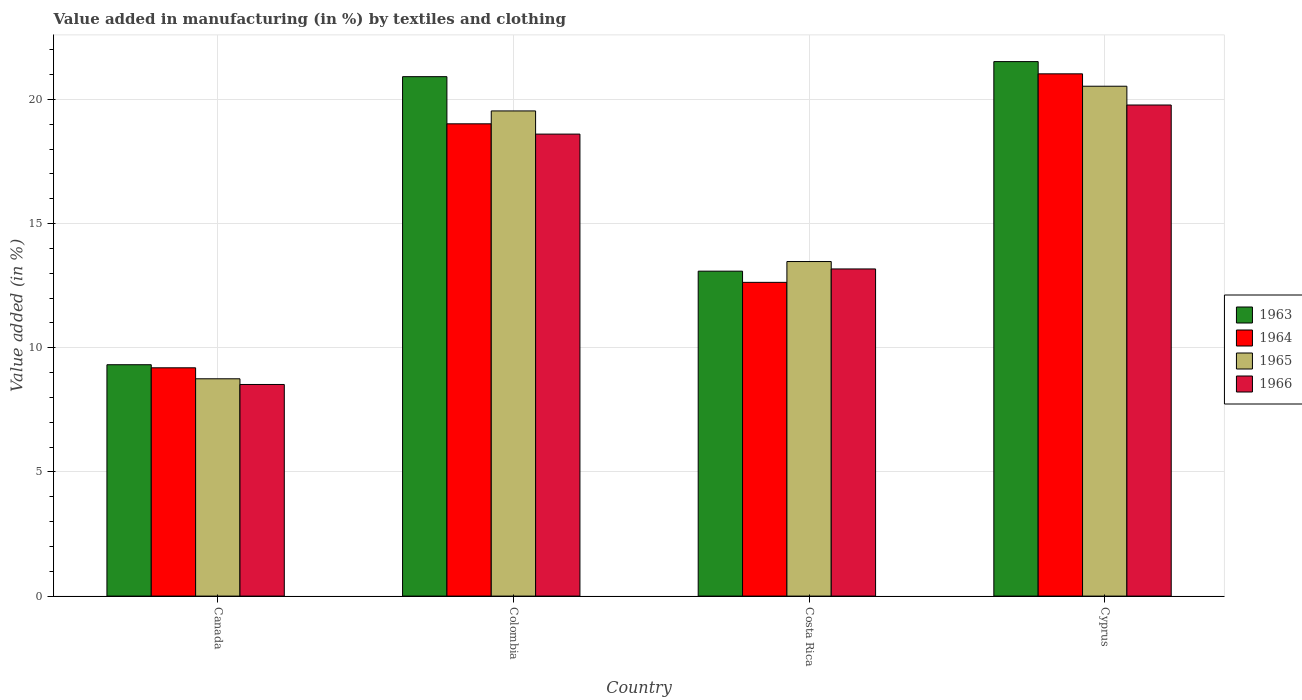How many different coloured bars are there?
Provide a short and direct response. 4. What is the label of the 3rd group of bars from the left?
Provide a short and direct response. Costa Rica. What is the percentage of value added in manufacturing by textiles and clothing in 1966 in Canada?
Your response must be concise. 8.52. Across all countries, what is the maximum percentage of value added in manufacturing by textiles and clothing in 1964?
Offer a terse response. 21.03. Across all countries, what is the minimum percentage of value added in manufacturing by textiles and clothing in 1966?
Provide a succinct answer. 8.52. In which country was the percentage of value added in manufacturing by textiles and clothing in 1965 maximum?
Ensure brevity in your answer.  Cyprus. In which country was the percentage of value added in manufacturing by textiles and clothing in 1965 minimum?
Make the answer very short. Canada. What is the total percentage of value added in manufacturing by textiles and clothing in 1965 in the graph?
Keep it short and to the point. 62.29. What is the difference between the percentage of value added in manufacturing by textiles and clothing in 1965 in Colombia and that in Costa Rica?
Keep it short and to the point. 6.06. What is the difference between the percentage of value added in manufacturing by textiles and clothing in 1965 in Canada and the percentage of value added in manufacturing by textiles and clothing in 1966 in Costa Rica?
Keep it short and to the point. -4.42. What is the average percentage of value added in manufacturing by textiles and clothing in 1963 per country?
Offer a very short reply. 16.21. What is the difference between the percentage of value added in manufacturing by textiles and clothing of/in 1966 and percentage of value added in manufacturing by textiles and clothing of/in 1964 in Colombia?
Offer a terse response. -0.41. What is the ratio of the percentage of value added in manufacturing by textiles and clothing in 1966 in Colombia to that in Cyprus?
Give a very brief answer. 0.94. Is the percentage of value added in manufacturing by textiles and clothing in 1965 in Colombia less than that in Costa Rica?
Your answer should be compact. No. Is the difference between the percentage of value added in manufacturing by textiles and clothing in 1966 in Canada and Colombia greater than the difference between the percentage of value added in manufacturing by textiles and clothing in 1964 in Canada and Colombia?
Provide a short and direct response. No. What is the difference between the highest and the second highest percentage of value added in manufacturing by textiles and clothing in 1963?
Your answer should be very brief. -7.83. What is the difference between the highest and the lowest percentage of value added in manufacturing by textiles and clothing in 1963?
Your answer should be compact. 12.21. In how many countries, is the percentage of value added in manufacturing by textiles and clothing in 1963 greater than the average percentage of value added in manufacturing by textiles and clothing in 1963 taken over all countries?
Provide a short and direct response. 2. Is the sum of the percentage of value added in manufacturing by textiles and clothing in 1965 in Canada and Costa Rica greater than the maximum percentage of value added in manufacturing by textiles and clothing in 1964 across all countries?
Give a very brief answer. Yes. What does the 2nd bar from the left in Colombia represents?
Provide a succinct answer. 1964. What does the 1st bar from the right in Canada represents?
Ensure brevity in your answer.  1966. Is it the case that in every country, the sum of the percentage of value added in manufacturing by textiles and clothing in 1966 and percentage of value added in manufacturing by textiles and clothing in 1965 is greater than the percentage of value added in manufacturing by textiles and clothing in 1964?
Ensure brevity in your answer.  Yes. How many countries are there in the graph?
Offer a terse response. 4. Does the graph contain grids?
Give a very brief answer. Yes. Where does the legend appear in the graph?
Keep it short and to the point. Center right. How are the legend labels stacked?
Ensure brevity in your answer.  Vertical. What is the title of the graph?
Offer a terse response. Value added in manufacturing (in %) by textiles and clothing. What is the label or title of the Y-axis?
Offer a terse response. Value added (in %). What is the Value added (in %) in 1963 in Canada?
Your answer should be very brief. 9.32. What is the Value added (in %) of 1964 in Canada?
Keep it short and to the point. 9.19. What is the Value added (in %) in 1965 in Canada?
Your response must be concise. 8.75. What is the Value added (in %) of 1966 in Canada?
Your answer should be compact. 8.52. What is the Value added (in %) of 1963 in Colombia?
Your answer should be very brief. 20.92. What is the Value added (in %) of 1964 in Colombia?
Your answer should be compact. 19.02. What is the Value added (in %) of 1965 in Colombia?
Make the answer very short. 19.54. What is the Value added (in %) of 1966 in Colombia?
Offer a very short reply. 18.6. What is the Value added (in %) of 1963 in Costa Rica?
Your response must be concise. 13.08. What is the Value added (in %) in 1964 in Costa Rica?
Your response must be concise. 12.63. What is the Value added (in %) in 1965 in Costa Rica?
Offer a very short reply. 13.47. What is the Value added (in %) in 1966 in Costa Rica?
Provide a succinct answer. 13.17. What is the Value added (in %) of 1963 in Cyprus?
Your answer should be very brief. 21.52. What is the Value added (in %) in 1964 in Cyprus?
Offer a very short reply. 21.03. What is the Value added (in %) in 1965 in Cyprus?
Provide a succinct answer. 20.53. What is the Value added (in %) in 1966 in Cyprus?
Give a very brief answer. 19.78. Across all countries, what is the maximum Value added (in %) of 1963?
Give a very brief answer. 21.52. Across all countries, what is the maximum Value added (in %) of 1964?
Your response must be concise. 21.03. Across all countries, what is the maximum Value added (in %) of 1965?
Make the answer very short. 20.53. Across all countries, what is the maximum Value added (in %) in 1966?
Make the answer very short. 19.78. Across all countries, what is the minimum Value added (in %) in 1963?
Keep it short and to the point. 9.32. Across all countries, what is the minimum Value added (in %) in 1964?
Provide a short and direct response. 9.19. Across all countries, what is the minimum Value added (in %) of 1965?
Make the answer very short. 8.75. Across all countries, what is the minimum Value added (in %) of 1966?
Keep it short and to the point. 8.52. What is the total Value added (in %) of 1963 in the graph?
Provide a succinct answer. 64.84. What is the total Value added (in %) of 1964 in the graph?
Your answer should be compact. 61.88. What is the total Value added (in %) of 1965 in the graph?
Your answer should be compact. 62.29. What is the total Value added (in %) in 1966 in the graph?
Offer a terse response. 60.08. What is the difference between the Value added (in %) of 1963 in Canada and that in Colombia?
Make the answer very short. -11.6. What is the difference between the Value added (in %) in 1964 in Canada and that in Colombia?
Your answer should be very brief. -9.82. What is the difference between the Value added (in %) in 1965 in Canada and that in Colombia?
Offer a very short reply. -10.79. What is the difference between the Value added (in %) of 1966 in Canada and that in Colombia?
Offer a very short reply. -10.08. What is the difference between the Value added (in %) of 1963 in Canada and that in Costa Rica?
Give a very brief answer. -3.77. What is the difference between the Value added (in %) of 1964 in Canada and that in Costa Rica?
Provide a succinct answer. -3.44. What is the difference between the Value added (in %) of 1965 in Canada and that in Costa Rica?
Offer a very short reply. -4.72. What is the difference between the Value added (in %) of 1966 in Canada and that in Costa Rica?
Keep it short and to the point. -4.65. What is the difference between the Value added (in %) in 1963 in Canada and that in Cyprus?
Ensure brevity in your answer.  -12.21. What is the difference between the Value added (in %) of 1964 in Canada and that in Cyprus?
Offer a very short reply. -11.84. What is the difference between the Value added (in %) in 1965 in Canada and that in Cyprus?
Provide a succinct answer. -11.78. What is the difference between the Value added (in %) of 1966 in Canada and that in Cyprus?
Offer a terse response. -11.25. What is the difference between the Value added (in %) of 1963 in Colombia and that in Costa Rica?
Offer a terse response. 7.83. What is the difference between the Value added (in %) in 1964 in Colombia and that in Costa Rica?
Offer a very short reply. 6.38. What is the difference between the Value added (in %) in 1965 in Colombia and that in Costa Rica?
Offer a terse response. 6.06. What is the difference between the Value added (in %) of 1966 in Colombia and that in Costa Rica?
Your answer should be very brief. 5.43. What is the difference between the Value added (in %) in 1963 in Colombia and that in Cyprus?
Your answer should be compact. -0.61. What is the difference between the Value added (in %) of 1964 in Colombia and that in Cyprus?
Offer a terse response. -2.01. What is the difference between the Value added (in %) of 1965 in Colombia and that in Cyprus?
Offer a terse response. -0.99. What is the difference between the Value added (in %) of 1966 in Colombia and that in Cyprus?
Make the answer very short. -1.17. What is the difference between the Value added (in %) of 1963 in Costa Rica and that in Cyprus?
Offer a terse response. -8.44. What is the difference between the Value added (in %) of 1964 in Costa Rica and that in Cyprus?
Your answer should be very brief. -8.4. What is the difference between the Value added (in %) of 1965 in Costa Rica and that in Cyprus?
Ensure brevity in your answer.  -7.06. What is the difference between the Value added (in %) of 1966 in Costa Rica and that in Cyprus?
Offer a very short reply. -6.6. What is the difference between the Value added (in %) of 1963 in Canada and the Value added (in %) of 1964 in Colombia?
Your answer should be very brief. -9.7. What is the difference between the Value added (in %) of 1963 in Canada and the Value added (in %) of 1965 in Colombia?
Your answer should be very brief. -10.22. What is the difference between the Value added (in %) in 1963 in Canada and the Value added (in %) in 1966 in Colombia?
Offer a terse response. -9.29. What is the difference between the Value added (in %) in 1964 in Canada and the Value added (in %) in 1965 in Colombia?
Ensure brevity in your answer.  -10.34. What is the difference between the Value added (in %) of 1964 in Canada and the Value added (in %) of 1966 in Colombia?
Keep it short and to the point. -9.41. What is the difference between the Value added (in %) of 1965 in Canada and the Value added (in %) of 1966 in Colombia?
Provide a succinct answer. -9.85. What is the difference between the Value added (in %) of 1963 in Canada and the Value added (in %) of 1964 in Costa Rica?
Offer a very short reply. -3.32. What is the difference between the Value added (in %) of 1963 in Canada and the Value added (in %) of 1965 in Costa Rica?
Give a very brief answer. -4.16. What is the difference between the Value added (in %) in 1963 in Canada and the Value added (in %) in 1966 in Costa Rica?
Provide a short and direct response. -3.86. What is the difference between the Value added (in %) in 1964 in Canada and the Value added (in %) in 1965 in Costa Rica?
Your answer should be very brief. -4.28. What is the difference between the Value added (in %) of 1964 in Canada and the Value added (in %) of 1966 in Costa Rica?
Your response must be concise. -3.98. What is the difference between the Value added (in %) in 1965 in Canada and the Value added (in %) in 1966 in Costa Rica?
Give a very brief answer. -4.42. What is the difference between the Value added (in %) in 1963 in Canada and the Value added (in %) in 1964 in Cyprus?
Your response must be concise. -11.71. What is the difference between the Value added (in %) in 1963 in Canada and the Value added (in %) in 1965 in Cyprus?
Offer a terse response. -11.21. What is the difference between the Value added (in %) of 1963 in Canada and the Value added (in %) of 1966 in Cyprus?
Offer a very short reply. -10.46. What is the difference between the Value added (in %) of 1964 in Canada and the Value added (in %) of 1965 in Cyprus?
Ensure brevity in your answer.  -11.34. What is the difference between the Value added (in %) of 1964 in Canada and the Value added (in %) of 1966 in Cyprus?
Give a very brief answer. -10.58. What is the difference between the Value added (in %) in 1965 in Canada and the Value added (in %) in 1966 in Cyprus?
Provide a succinct answer. -11.02. What is the difference between the Value added (in %) in 1963 in Colombia and the Value added (in %) in 1964 in Costa Rica?
Provide a succinct answer. 8.28. What is the difference between the Value added (in %) of 1963 in Colombia and the Value added (in %) of 1965 in Costa Rica?
Ensure brevity in your answer.  7.44. What is the difference between the Value added (in %) in 1963 in Colombia and the Value added (in %) in 1966 in Costa Rica?
Your answer should be compact. 7.74. What is the difference between the Value added (in %) of 1964 in Colombia and the Value added (in %) of 1965 in Costa Rica?
Keep it short and to the point. 5.55. What is the difference between the Value added (in %) of 1964 in Colombia and the Value added (in %) of 1966 in Costa Rica?
Keep it short and to the point. 5.84. What is the difference between the Value added (in %) in 1965 in Colombia and the Value added (in %) in 1966 in Costa Rica?
Ensure brevity in your answer.  6.36. What is the difference between the Value added (in %) of 1963 in Colombia and the Value added (in %) of 1964 in Cyprus?
Keep it short and to the point. -0.11. What is the difference between the Value added (in %) in 1963 in Colombia and the Value added (in %) in 1965 in Cyprus?
Offer a terse response. 0.39. What is the difference between the Value added (in %) in 1963 in Colombia and the Value added (in %) in 1966 in Cyprus?
Your answer should be very brief. 1.14. What is the difference between the Value added (in %) of 1964 in Colombia and the Value added (in %) of 1965 in Cyprus?
Your answer should be very brief. -1.51. What is the difference between the Value added (in %) in 1964 in Colombia and the Value added (in %) in 1966 in Cyprus?
Make the answer very short. -0.76. What is the difference between the Value added (in %) in 1965 in Colombia and the Value added (in %) in 1966 in Cyprus?
Provide a succinct answer. -0.24. What is the difference between the Value added (in %) of 1963 in Costa Rica and the Value added (in %) of 1964 in Cyprus?
Your answer should be very brief. -7.95. What is the difference between the Value added (in %) in 1963 in Costa Rica and the Value added (in %) in 1965 in Cyprus?
Provide a succinct answer. -7.45. What is the difference between the Value added (in %) of 1963 in Costa Rica and the Value added (in %) of 1966 in Cyprus?
Make the answer very short. -6.69. What is the difference between the Value added (in %) of 1964 in Costa Rica and the Value added (in %) of 1965 in Cyprus?
Provide a short and direct response. -7.9. What is the difference between the Value added (in %) in 1964 in Costa Rica and the Value added (in %) in 1966 in Cyprus?
Offer a terse response. -7.14. What is the difference between the Value added (in %) in 1965 in Costa Rica and the Value added (in %) in 1966 in Cyprus?
Keep it short and to the point. -6.3. What is the average Value added (in %) of 1963 per country?
Your answer should be compact. 16.21. What is the average Value added (in %) in 1964 per country?
Give a very brief answer. 15.47. What is the average Value added (in %) of 1965 per country?
Your answer should be very brief. 15.57. What is the average Value added (in %) of 1966 per country?
Provide a short and direct response. 15.02. What is the difference between the Value added (in %) in 1963 and Value added (in %) in 1964 in Canada?
Give a very brief answer. 0.12. What is the difference between the Value added (in %) in 1963 and Value added (in %) in 1965 in Canada?
Your response must be concise. 0.57. What is the difference between the Value added (in %) in 1963 and Value added (in %) in 1966 in Canada?
Keep it short and to the point. 0.8. What is the difference between the Value added (in %) of 1964 and Value added (in %) of 1965 in Canada?
Make the answer very short. 0.44. What is the difference between the Value added (in %) of 1964 and Value added (in %) of 1966 in Canada?
Provide a succinct answer. 0.67. What is the difference between the Value added (in %) of 1965 and Value added (in %) of 1966 in Canada?
Offer a terse response. 0.23. What is the difference between the Value added (in %) of 1963 and Value added (in %) of 1964 in Colombia?
Your answer should be very brief. 1.9. What is the difference between the Value added (in %) of 1963 and Value added (in %) of 1965 in Colombia?
Offer a terse response. 1.38. What is the difference between the Value added (in %) of 1963 and Value added (in %) of 1966 in Colombia?
Provide a short and direct response. 2.31. What is the difference between the Value added (in %) in 1964 and Value added (in %) in 1965 in Colombia?
Make the answer very short. -0.52. What is the difference between the Value added (in %) of 1964 and Value added (in %) of 1966 in Colombia?
Keep it short and to the point. 0.41. What is the difference between the Value added (in %) of 1965 and Value added (in %) of 1966 in Colombia?
Offer a very short reply. 0.93. What is the difference between the Value added (in %) in 1963 and Value added (in %) in 1964 in Costa Rica?
Your response must be concise. 0.45. What is the difference between the Value added (in %) of 1963 and Value added (in %) of 1965 in Costa Rica?
Your answer should be very brief. -0.39. What is the difference between the Value added (in %) in 1963 and Value added (in %) in 1966 in Costa Rica?
Your response must be concise. -0.09. What is the difference between the Value added (in %) in 1964 and Value added (in %) in 1965 in Costa Rica?
Offer a very short reply. -0.84. What is the difference between the Value added (in %) in 1964 and Value added (in %) in 1966 in Costa Rica?
Ensure brevity in your answer.  -0.54. What is the difference between the Value added (in %) of 1965 and Value added (in %) of 1966 in Costa Rica?
Ensure brevity in your answer.  0.3. What is the difference between the Value added (in %) in 1963 and Value added (in %) in 1964 in Cyprus?
Keep it short and to the point. 0.49. What is the difference between the Value added (in %) in 1963 and Value added (in %) in 1965 in Cyprus?
Your response must be concise. 0.99. What is the difference between the Value added (in %) in 1963 and Value added (in %) in 1966 in Cyprus?
Give a very brief answer. 1.75. What is the difference between the Value added (in %) of 1964 and Value added (in %) of 1965 in Cyprus?
Offer a very short reply. 0.5. What is the difference between the Value added (in %) in 1964 and Value added (in %) in 1966 in Cyprus?
Your answer should be very brief. 1.25. What is the difference between the Value added (in %) in 1965 and Value added (in %) in 1966 in Cyprus?
Your answer should be compact. 0.76. What is the ratio of the Value added (in %) of 1963 in Canada to that in Colombia?
Offer a terse response. 0.45. What is the ratio of the Value added (in %) of 1964 in Canada to that in Colombia?
Give a very brief answer. 0.48. What is the ratio of the Value added (in %) of 1965 in Canada to that in Colombia?
Your answer should be compact. 0.45. What is the ratio of the Value added (in %) in 1966 in Canada to that in Colombia?
Offer a terse response. 0.46. What is the ratio of the Value added (in %) in 1963 in Canada to that in Costa Rica?
Ensure brevity in your answer.  0.71. What is the ratio of the Value added (in %) of 1964 in Canada to that in Costa Rica?
Provide a succinct answer. 0.73. What is the ratio of the Value added (in %) of 1965 in Canada to that in Costa Rica?
Your response must be concise. 0.65. What is the ratio of the Value added (in %) in 1966 in Canada to that in Costa Rica?
Ensure brevity in your answer.  0.65. What is the ratio of the Value added (in %) in 1963 in Canada to that in Cyprus?
Keep it short and to the point. 0.43. What is the ratio of the Value added (in %) in 1964 in Canada to that in Cyprus?
Offer a very short reply. 0.44. What is the ratio of the Value added (in %) of 1965 in Canada to that in Cyprus?
Your answer should be very brief. 0.43. What is the ratio of the Value added (in %) in 1966 in Canada to that in Cyprus?
Offer a very short reply. 0.43. What is the ratio of the Value added (in %) in 1963 in Colombia to that in Costa Rica?
Provide a short and direct response. 1.6. What is the ratio of the Value added (in %) in 1964 in Colombia to that in Costa Rica?
Your response must be concise. 1.51. What is the ratio of the Value added (in %) in 1965 in Colombia to that in Costa Rica?
Provide a succinct answer. 1.45. What is the ratio of the Value added (in %) in 1966 in Colombia to that in Costa Rica?
Provide a succinct answer. 1.41. What is the ratio of the Value added (in %) of 1963 in Colombia to that in Cyprus?
Your answer should be compact. 0.97. What is the ratio of the Value added (in %) of 1964 in Colombia to that in Cyprus?
Offer a terse response. 0.9. What is the ratio of the Value added (in %) of 1965 in Colombia to that in Cyprus?
Ensure brevity in your answer.  0.95. What is the ratio of the Value added (in %) in 1966 in Colombia to that in Cyprus?
Make the answer very short. 0.94. What is the ratio of the Value added (in %) of 1963 in Costa Rica to that in Cyprus?
Ensure brevity in your answer.  0.61. What is the ratio of the Value added (in %) of 1964 in Costa Rica to that in Cyprus?
Your answer should be very brief. 0.6. What is the ratio of the Value added (in %) in 1965 in Costa Rica to that in Cyprus?
Provide a short and direct response. 0.66. What is the ratio of the Value added (in %) in 1966 in Costa Rica to that in Cyprus?
Your answer should be very brief. 0.67. What is the difference between the highest and the second highest Value added (in %) of 1963?
Offer a terse response. 0.61. What is the difference between the highest and the second highest Value added (in %) of 1964?
Offer a very short reply. 2.01. What is the difference between the highest and the second highest Value added (in %) of 1966?
Give a very brief answer. 1.17. What is the difference between the highest and the lowest Value added (in %) of 1963?
Provide a succinct answer. 12.21. What is the difference between the highest and the lowest Value added (in %) in 1964?
Your response must be concise. 11.84. What is the difference between the highest and the lowest Value added (in %) of 1965?
Give a very brief answer. 11.78. What is the difference between the highest and the lowest Value added (in %) in 1966?
Your response must be concise. 11.25. 